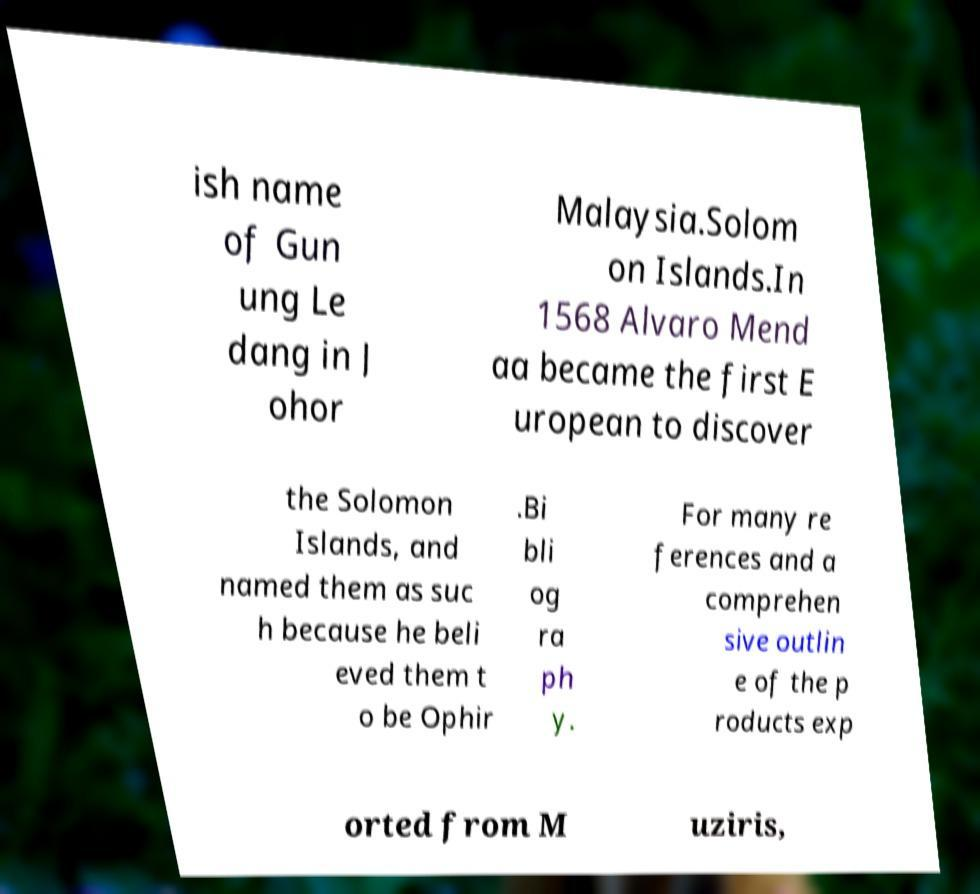Can you accurately transcribe the text from the provided image for me? ish name of Gun ung Le dang in J ohor Malaysia.Solom on Islands.In 1568 Alvaro Mend aa became the first E uropean to discover the Solomon Islands, and named them as suc h because he beli eved them t o be Ophir .Bi bli og ra ph y. For many re ferences and a comprehen sive outlin e of the p roducts exp orted from M uziris, 